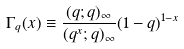<formula> <loc_0><loc_0><loc_500><loc_500>\Gamma _ { q } ( x ) \equiv \frac { ( q ; q ) _ { \infty } } { ( q ^ { x } ; q ) _ { \infty } } ( 1 - q ) ^ { 1 - x }</formula> 